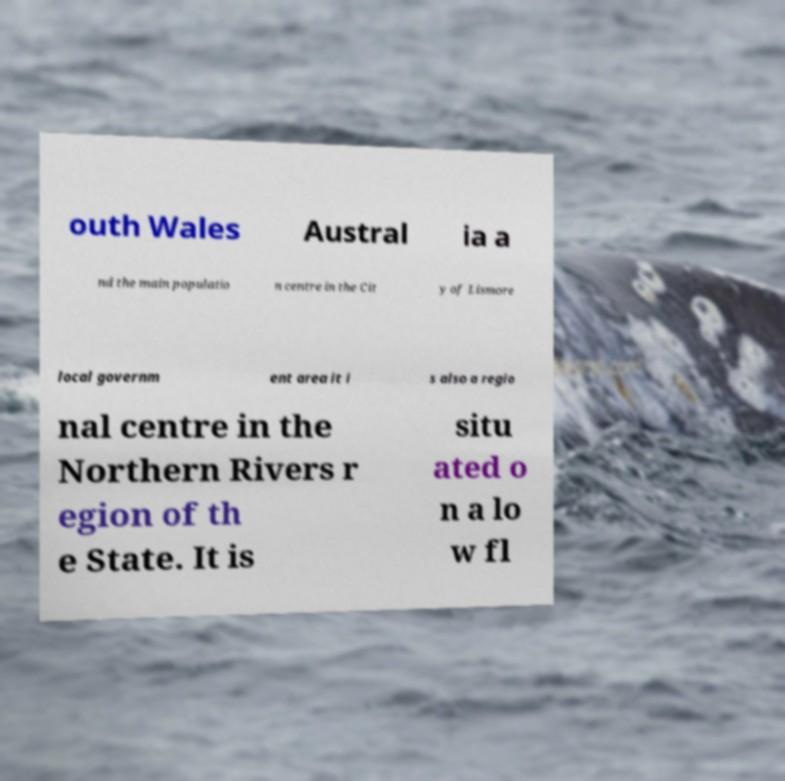Could you extract and type out the text from this image? outh Wales Austral ia a nd the main populatio n centre in the Cit y of Lismore local governm ent area it i s also a regio nal centre in the Northern Rivers r egion of th e State. It is situ ated o n a lo w fl 